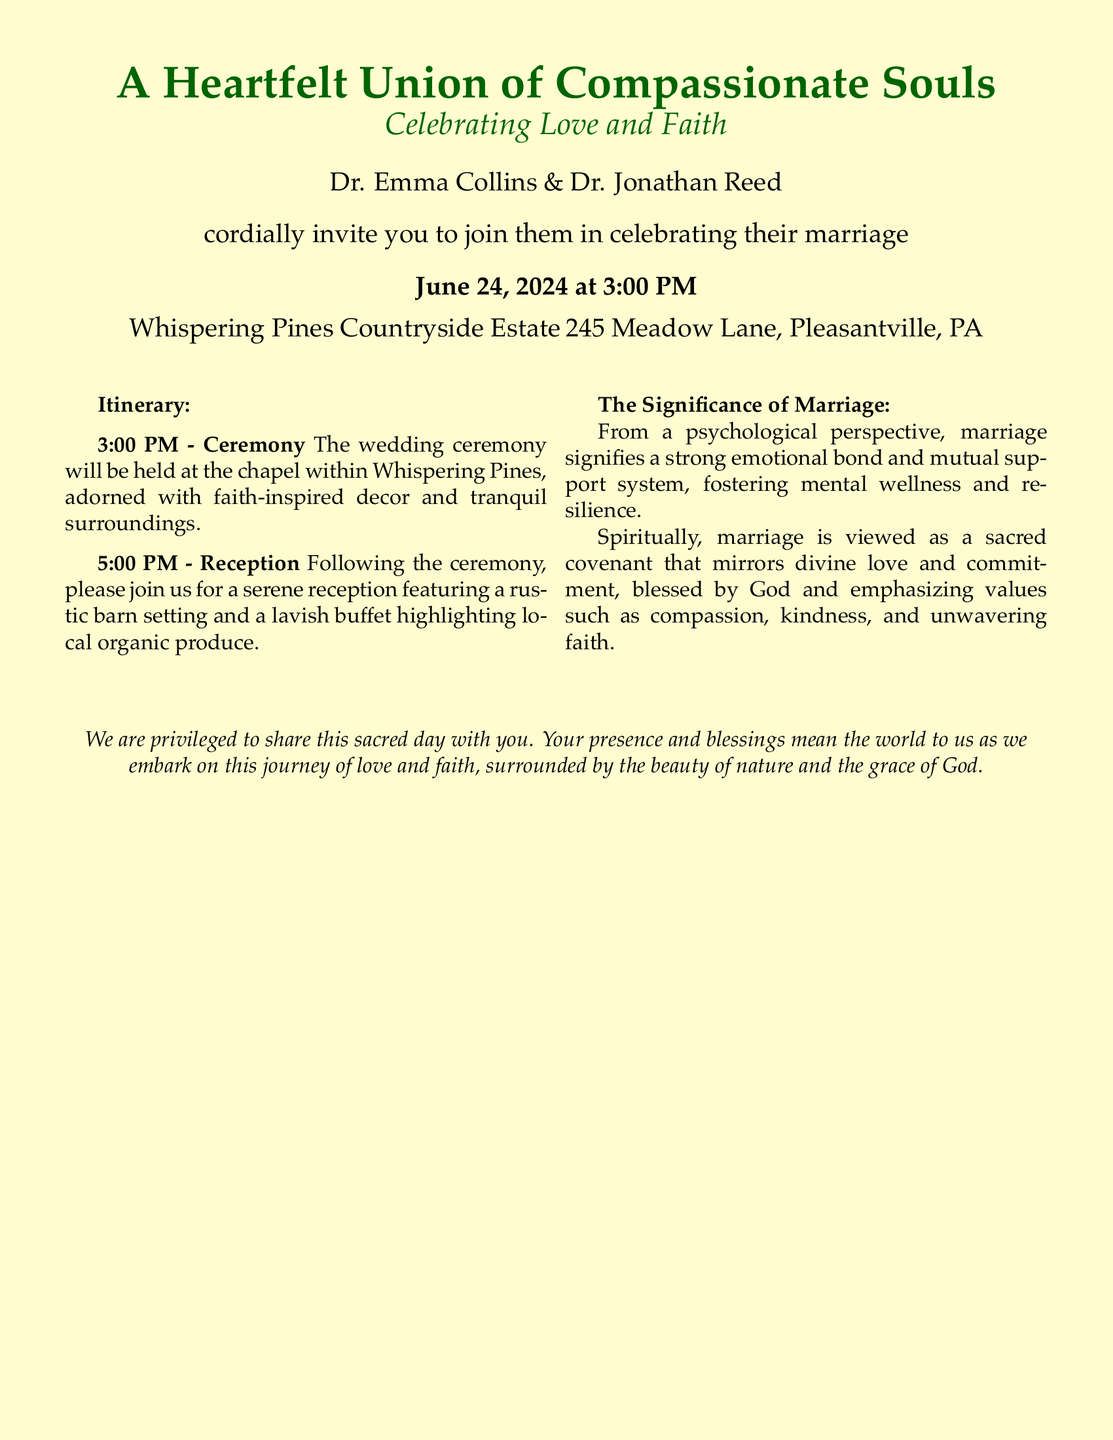What are the names of the couple? The document states the names of the couple as Dr. Emma Collins and Dr. Jonathan Reed.
Answer: Dr. Emma Collins & Dr. Jonathan Reed What is the wedding date? The document specifies that the wedding will take place on June 24, 2024.
Answer: June 24, 2024 What time does the ceremony start? The invitation indicates that the ceremony is scheduled to start at 3:00 PM.
Answer: 3:00 PM Where is the wedding taking place? The location provided in the document is Whispering Pines Countryside Estate.
Answer: Whispering Pines Countryside Estate What will follow the ceremony? According to the itinerary in the document, a reception will follow the ceremony.
Answer: Reception What time is the reception? The document states that the reception will start at 5:00 PM.
Answer: 5:00 PM What is one psychological benefit of marriage mentioned? The document describes that marriage fosters a strong emotional bond and mutual support system.
Answer: Emotional bond What is a spiritual view of marriage presented in the document? The document indicates that marriage is viewed as a sacred covenant mirroring divine love.
Answer: Sacred covenant What type of decor is mentioned for the ceremony? The document mentions that the chapel will be adorned with faith-inspired decor.
Answer: Faith-inspired decor 